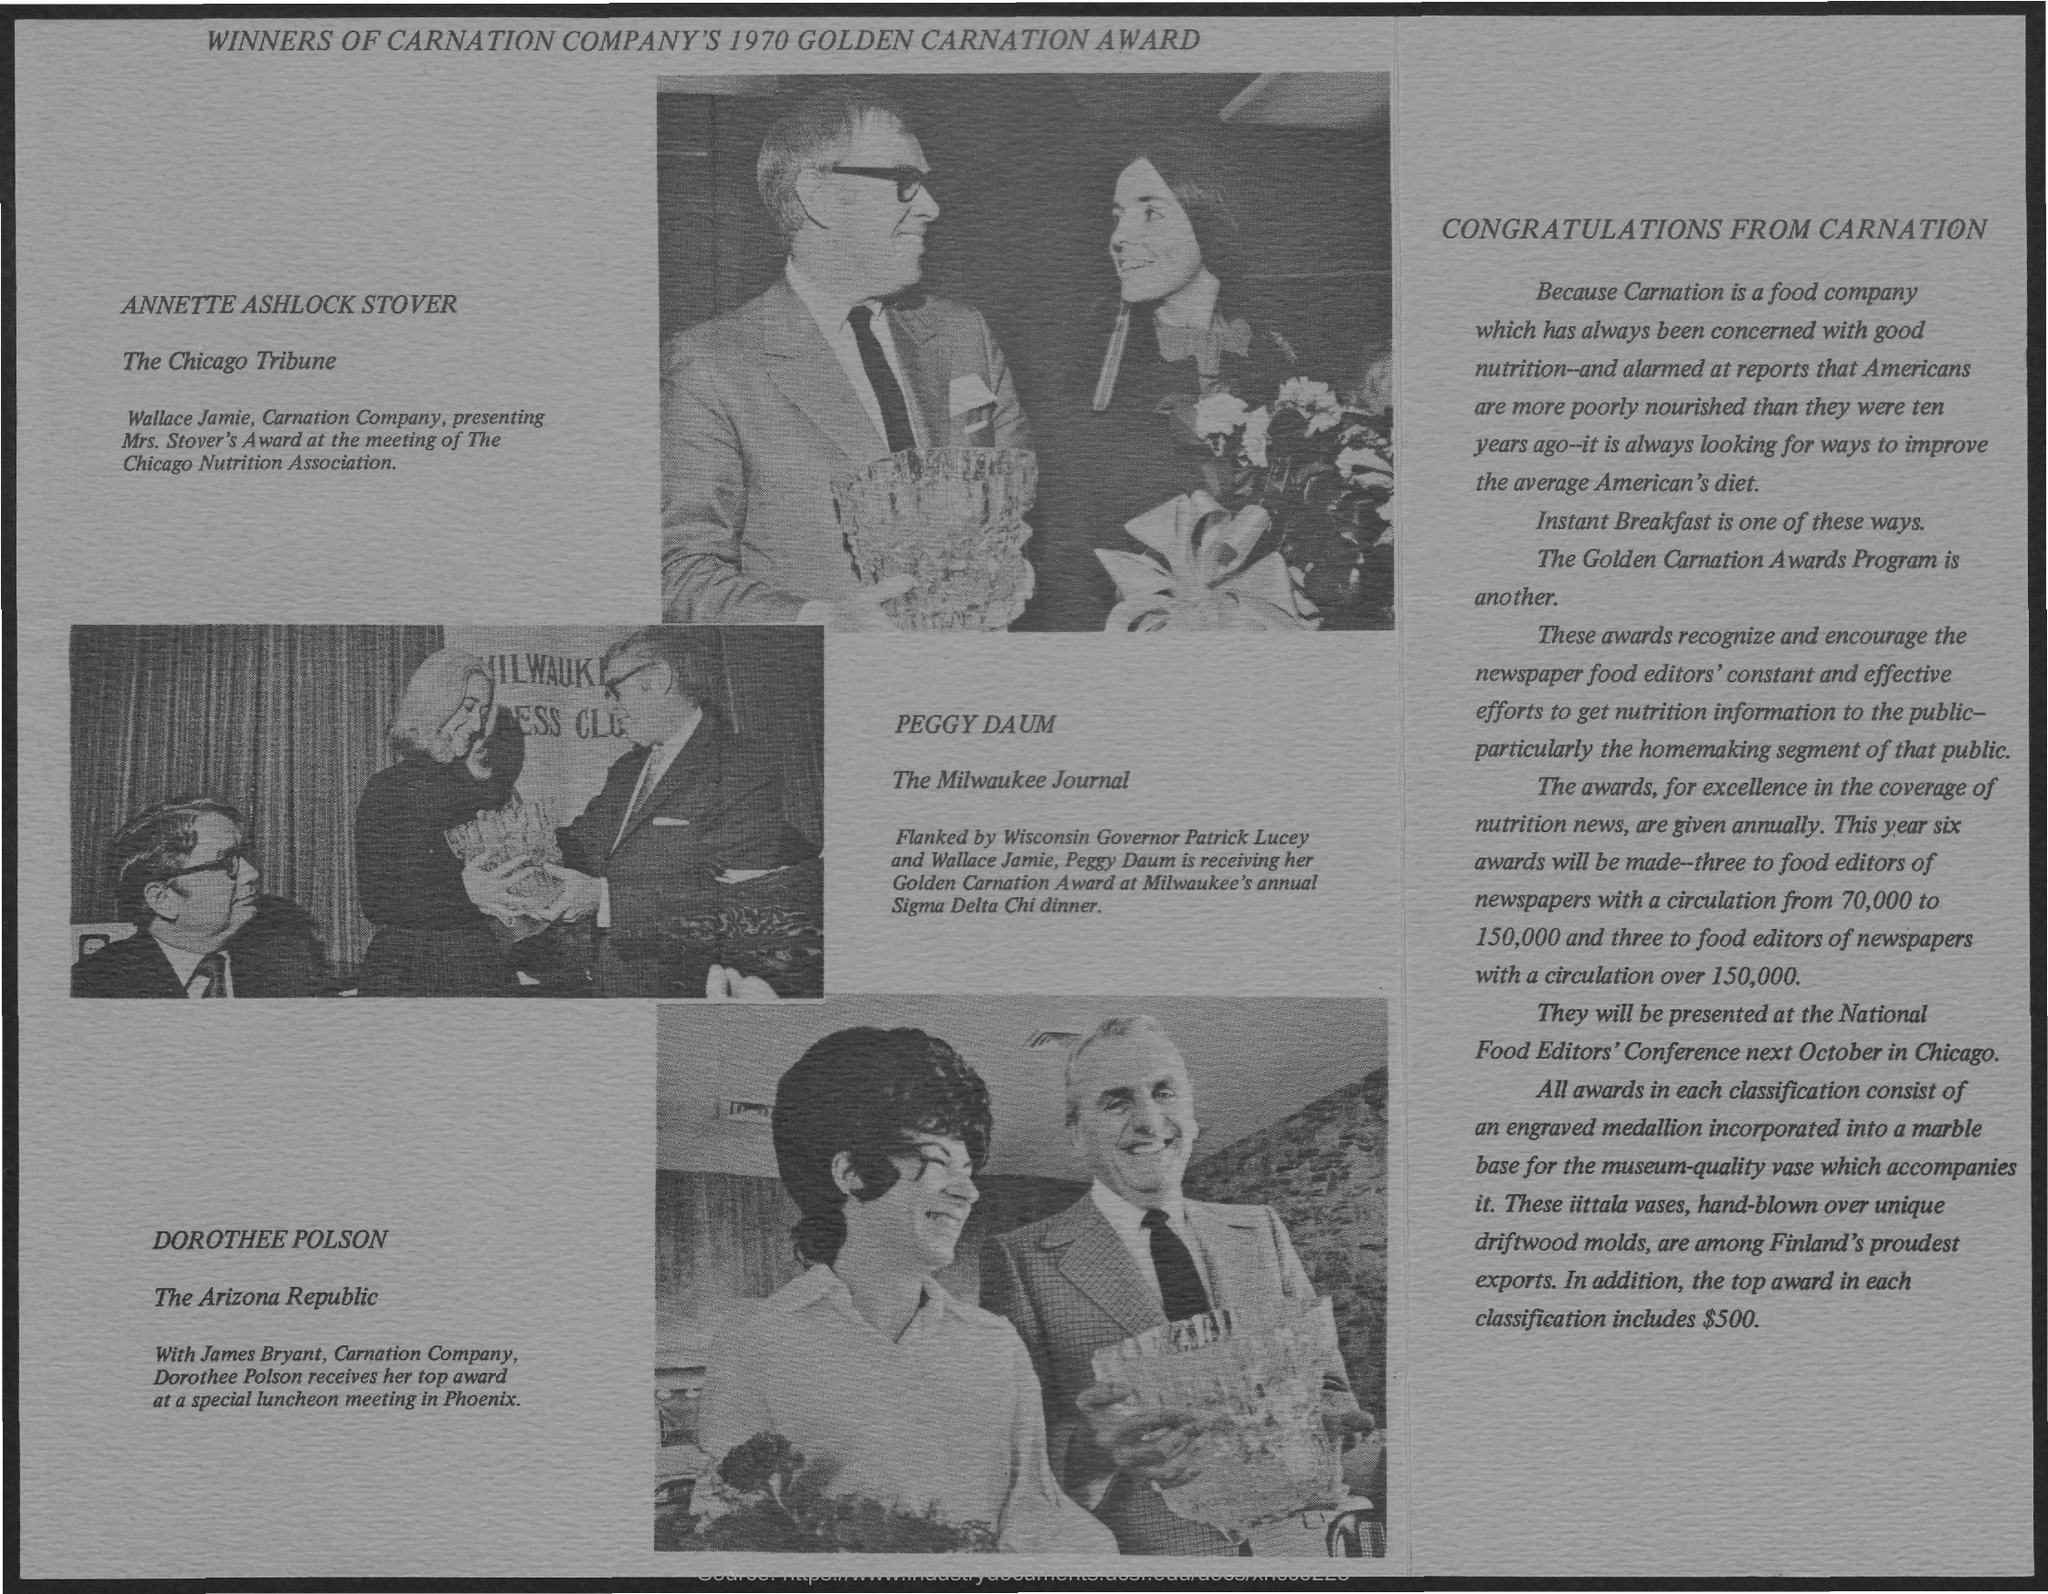Point out several critical features in this image. Peggy Daum is the recipient of the Golden Carnation Award. 